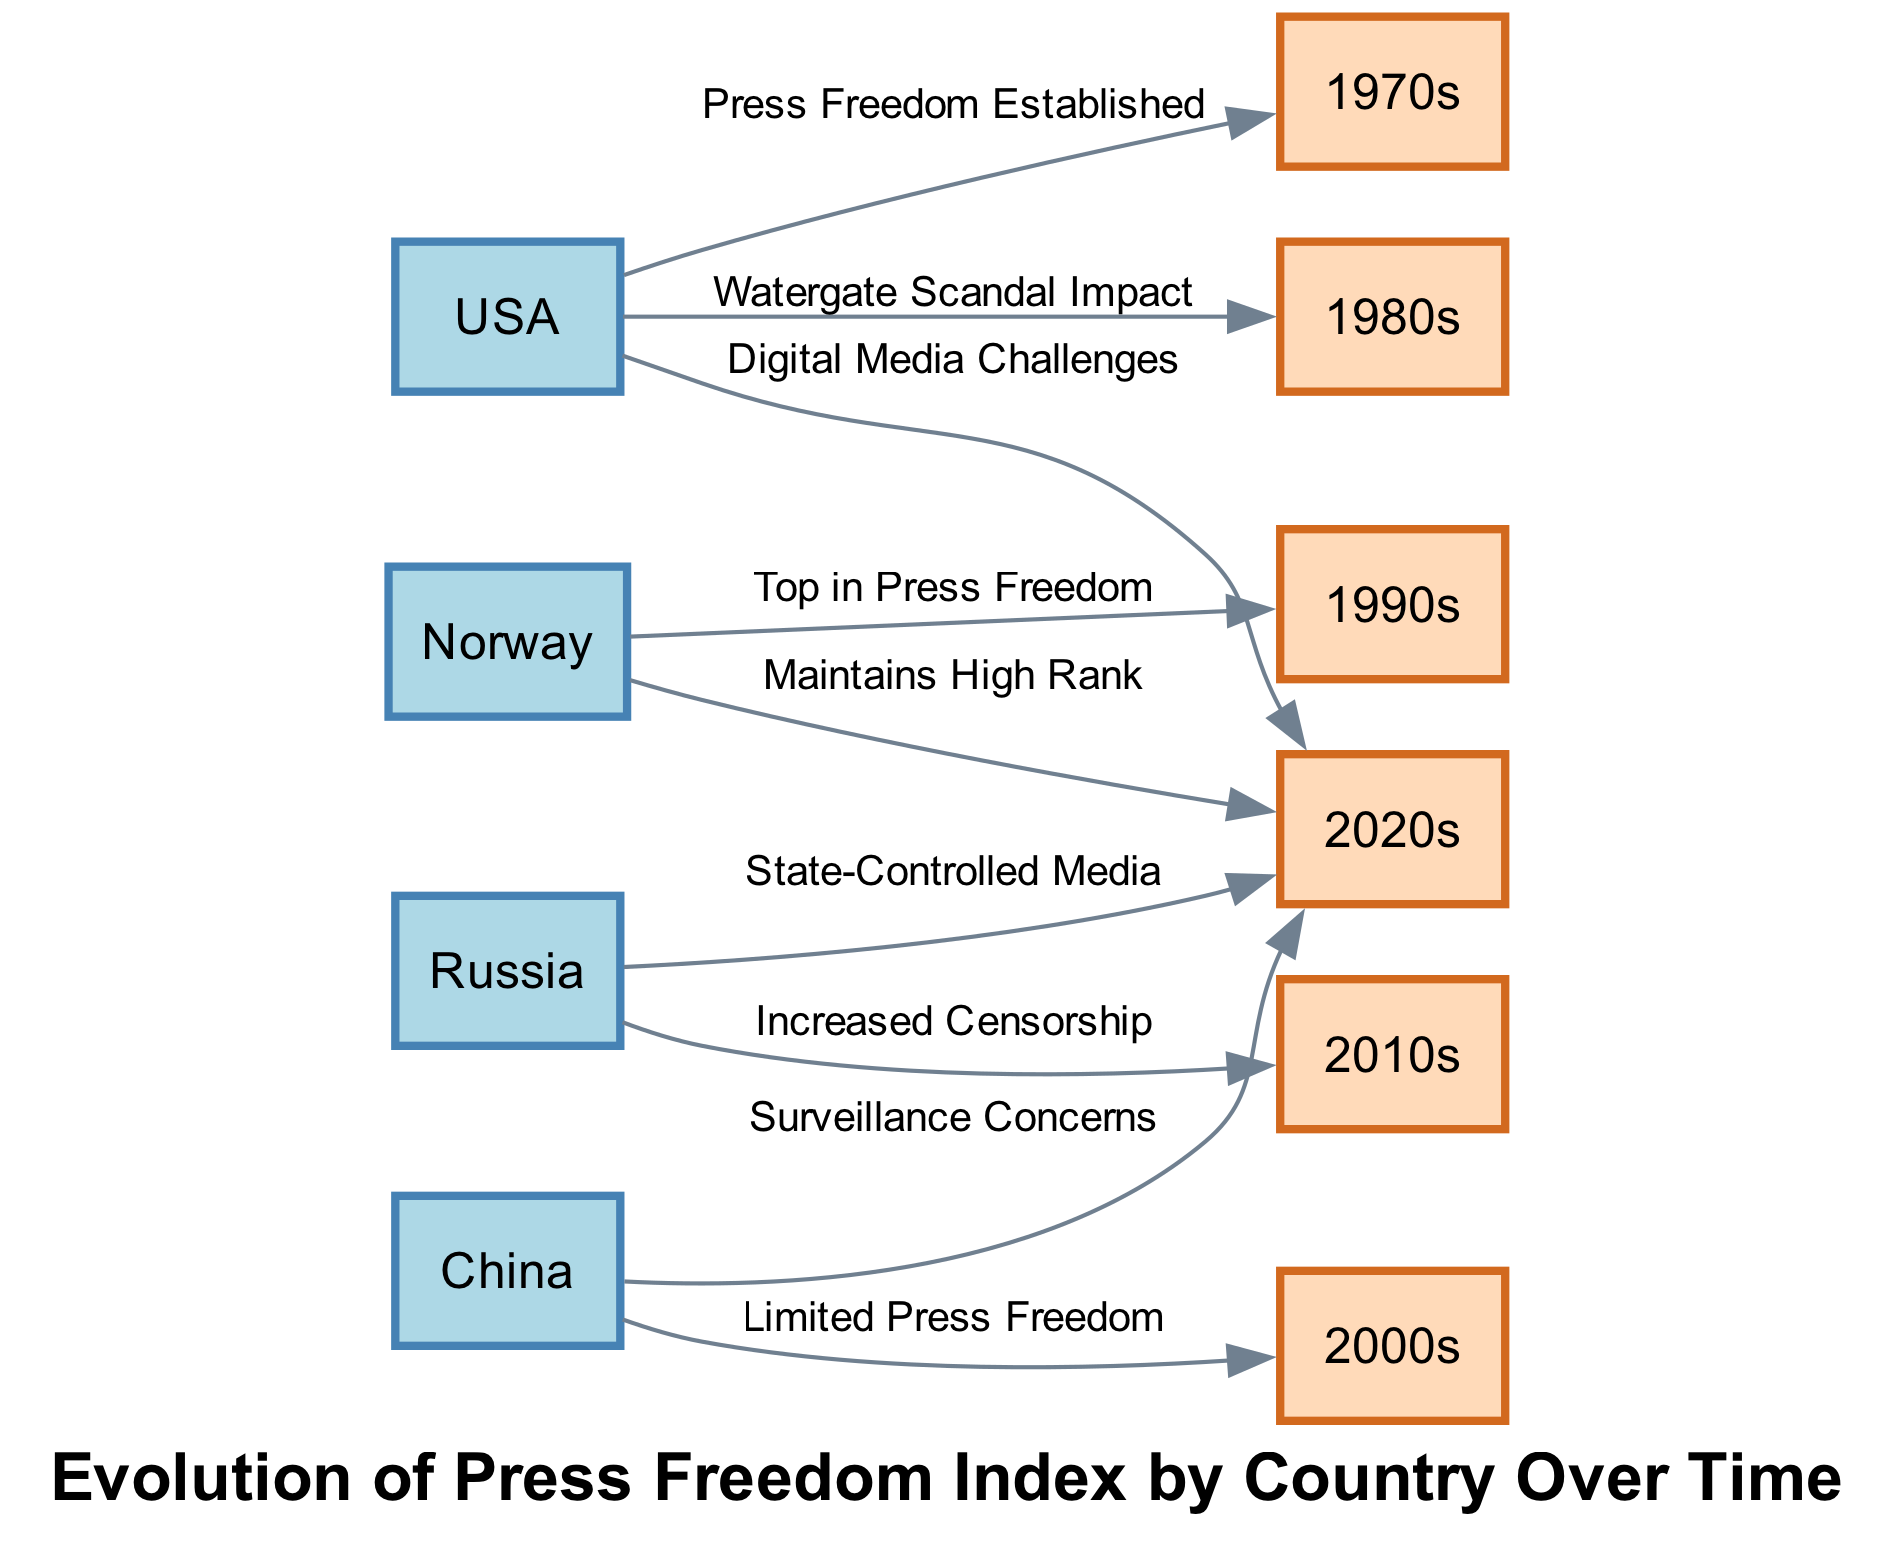What countries are represented in the diagram? The diagram includes four countries: USA, Norway, China, and Russia. Each country is a separate node indicating its press freedom index across different decades.
Answer: USA, Norway, China, Russia Which decade is represented as the peak for Norway in press freedom? According to the connections in the diagram, Norway is marked as "Top in Press Freedom" during the 1990s, making this the peak decade for Norway.
Answer: 1990s What is the relationship between China and the 2000s? The diagram states that China had "Limited Press Freedom" during the 2000s. This indicates a direct connection that highlights China’s situation regarding press freedom in that decade.
Answer: Limited Press Freedom How many total edges are present in the diagram? By counting the lines connecting the nodes, there are a total of eight edges that depict the relationships between the countries and decades.
Answer: 8 What has caused increased censorship in Russia according to the diagram? The edge from Russia to the 2010s states "Increased Censorship," indicating that the relationship is characterized by a situation where censorship levels rose during this period.
Answer: Increased Censorship Which country maintained its high rank in the 2020s? The diagram illustrates that Norway "Maintains High Rank" into the 2020s, signifying its continued status as a leader in press freedom.
Answer: Norway What is the implication of the label "Digital Media Challenges" for the USA? This label indicates that in the 2020s, the USA faced issues regarding digital media that could affect its press freedom, reflecting concerns in that timeframe related to media evolution.
Answer: Digital Media Challenges What trend can be identified for Russia from the 2000s to the 2020s? The trend shows that Russia's press freedom went from being unspecified during the 2000s to a label of "State-Controlled Media" in the 2020s, indicating a worsening situation for press freedom over those decades.
Answer: State-Controlled Media 